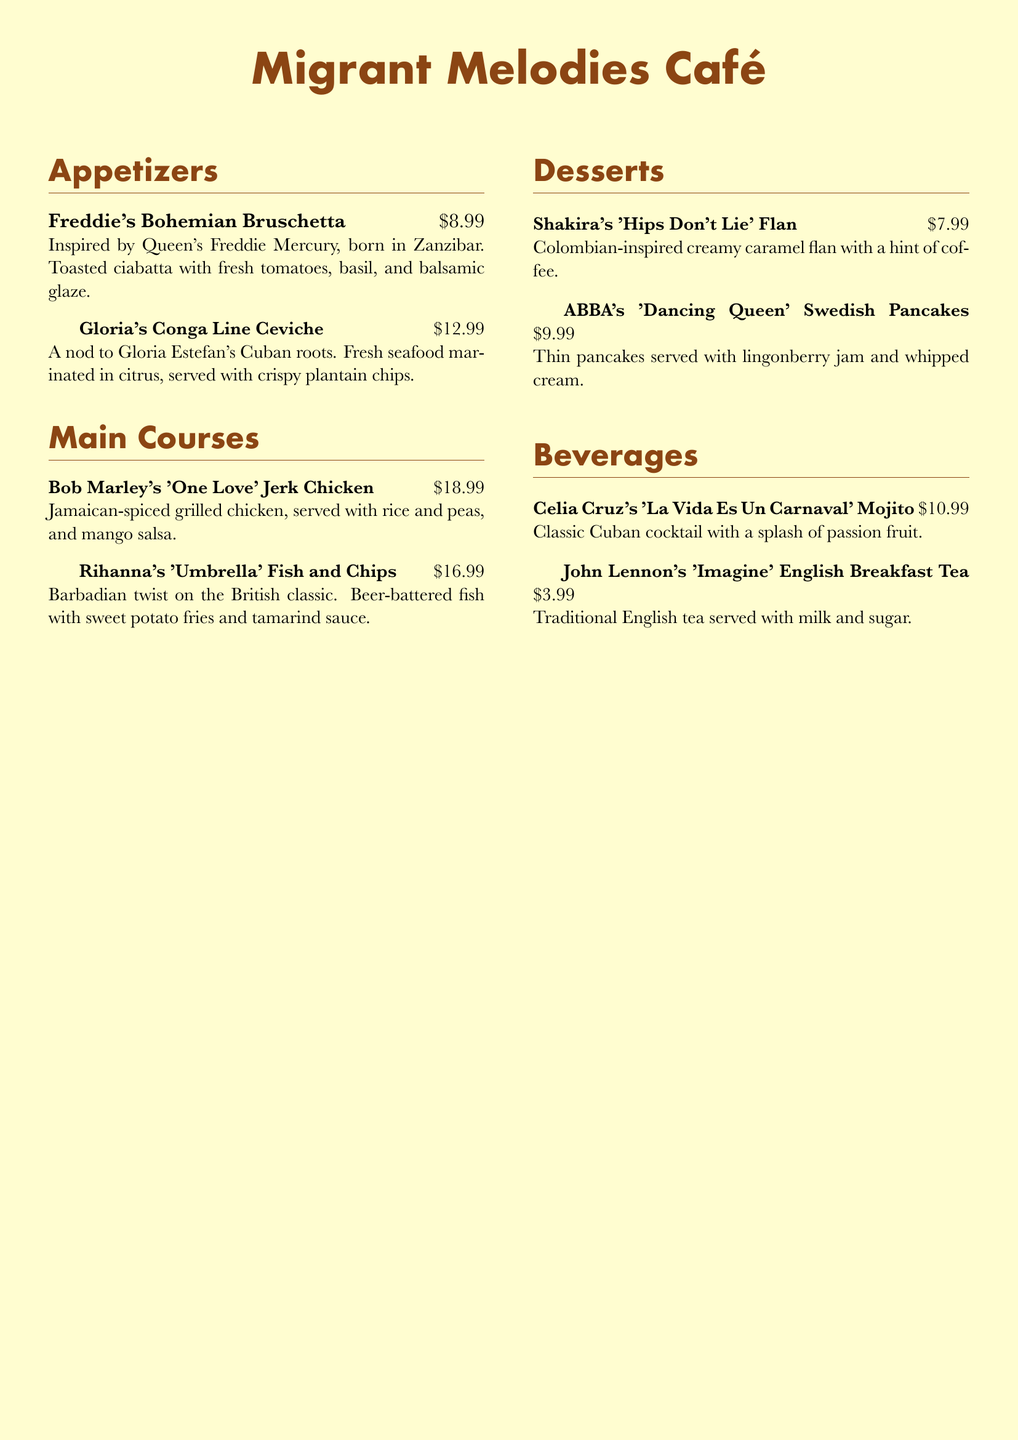what is the name of the café? The café is named "Migrant Melodies Café," which is stated prominently at the top of the document.
Answer: Migrant Melodies Café who inspired the 'Umbrella' Fish and Chips? The dish is inspired by Rihanna, who is mentioned in the description of the dish.
Answer: Rihanna how much does Freddie's Bohemian Bruschetta cost? The price for Freddie's Bohemian Bruschetta is clearly indicated next to the dish name.
Answer: $8.99 which dish is inspired by Colombian cuisine? The dessert "Shakira's 'Hips Don't Lie' Flan" is specifically mentioned to be Colombian-inspired.
Answer: Shakira's 'Hips Don't Lie' Flan what beverage is named after John Lennon? The beverage named after John Lennon is "Imagine" English Breakfast Tea, as noted in the beverages section.
Answer: Imagine English Breakfast Tea what type of dish is Gloria's Conga Line Ceviche? Gloria's Conga Line Ceviche is classified as an appetizer, according to the menu layout.
Answer: appetizer how many main courses are listed in the menu? The document lists two main courses in the main courses section.
Answer: 2 which musician's dish includes mango salsa? The dish associated with mango salsa is "Bob Marley's 'One Love' Jerk Chicken," as detailed in its description.
Answer: Bob Marley what is the main ingredient of Celia Cruz's mojito? The main ingredient in Celia Cruz's 'La Vida Es Un Carnaval' Mojito is identified as a classic Cuban cocktail.
Answer: classic Cuban cocktail 